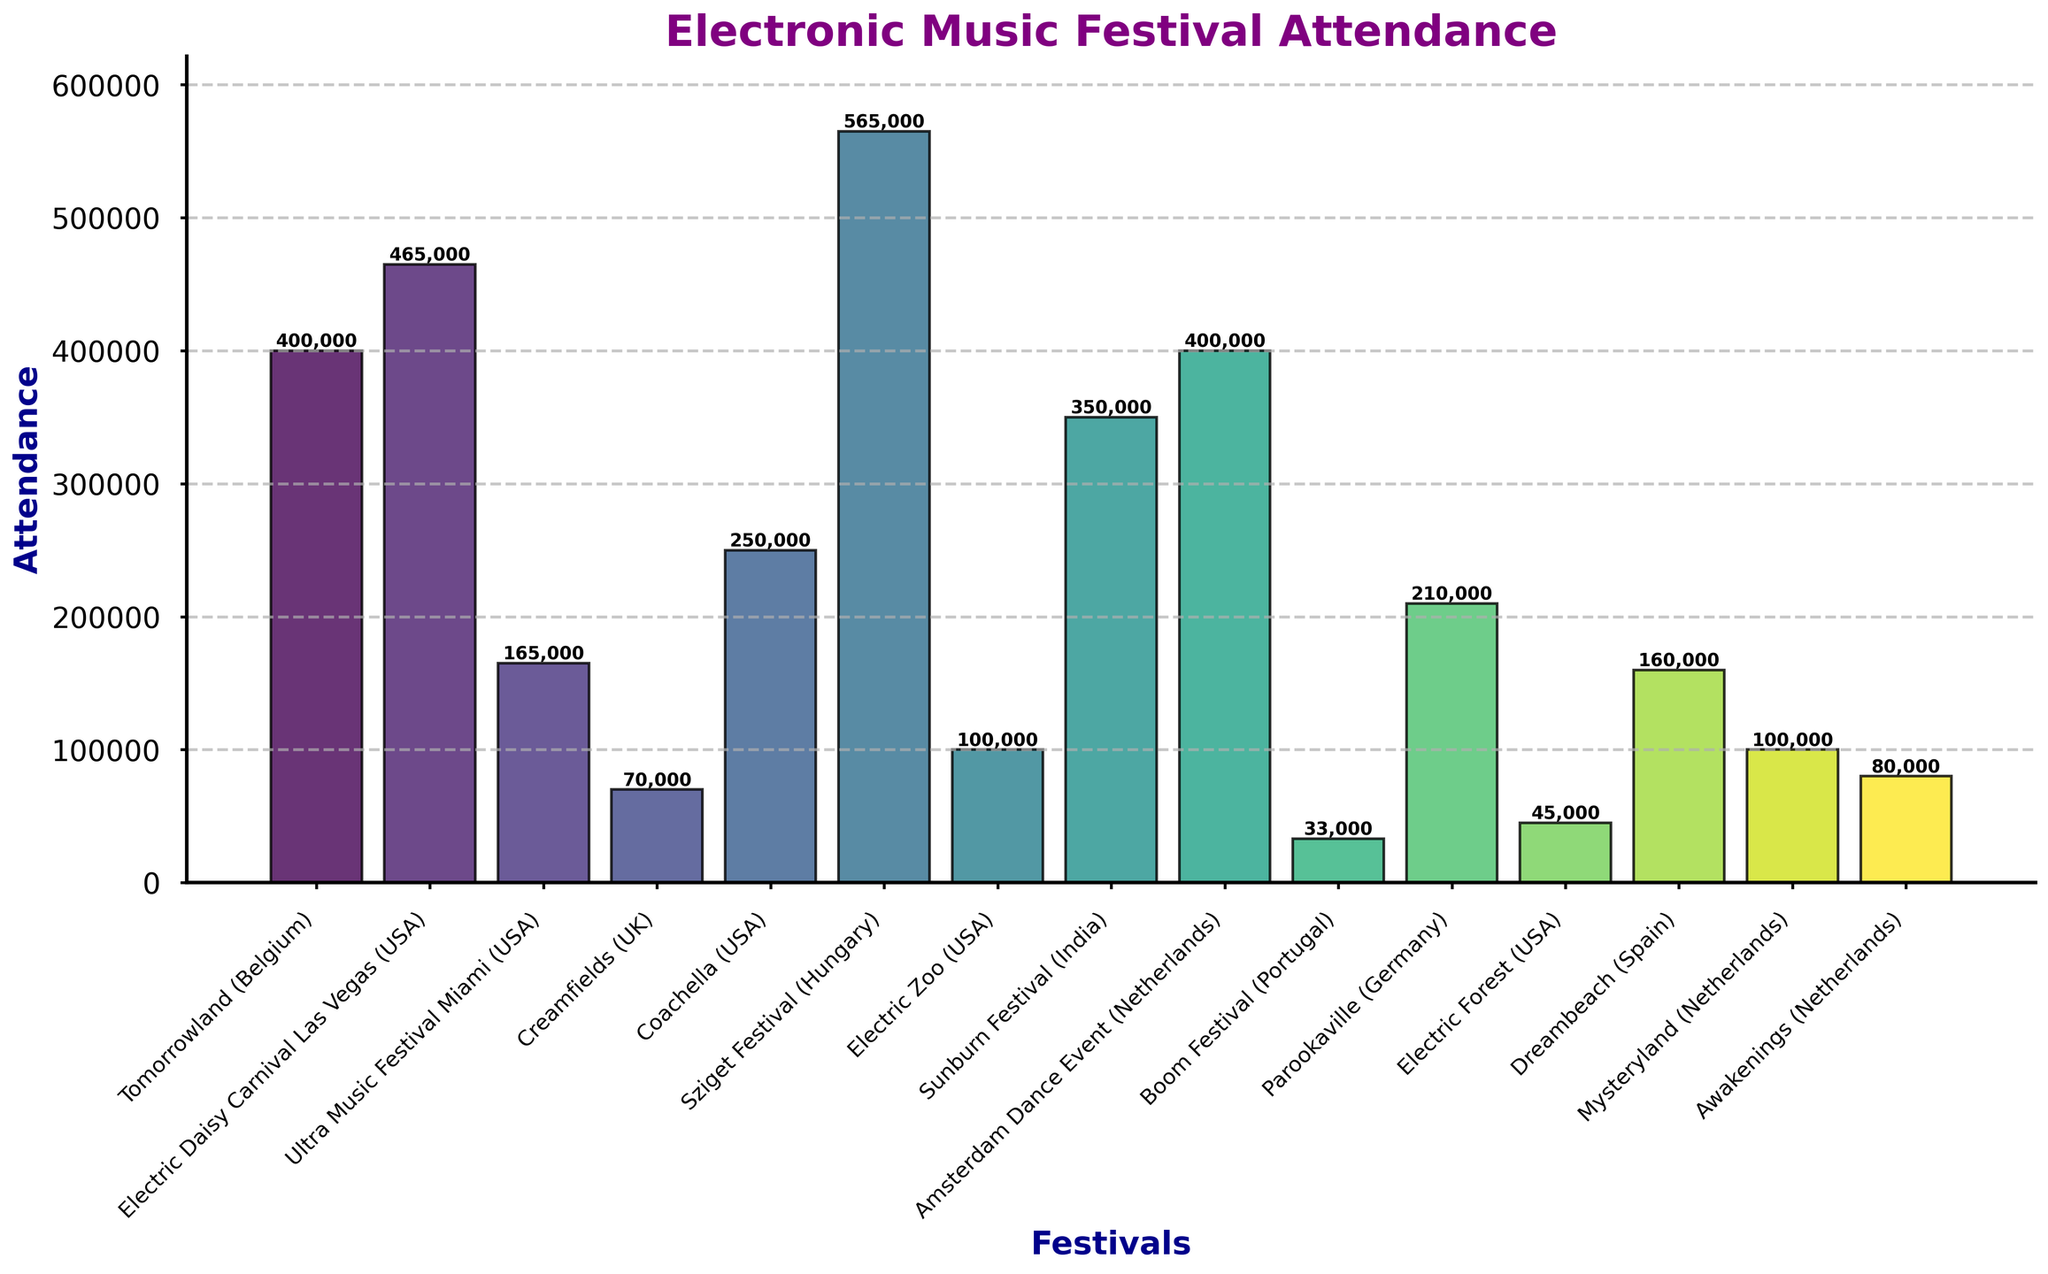Which festival has the highest attendance? The highest bar in the figure represents the festival with the highest attendance. By looking at the top of each bar, Sziget Festival in Hungary has the highest attendance of 565,000.
Answer: Sziget Festival (Hungary) Which festivals have equal attendance figures and what are they? By examining the height of the bars, Tomorrowland in Belgium and Amsterdam Dance Event in the Netherlands both have an attendance figure of 400,000.
Answer: Tomorrowland (Belgium) & Amsterdam Dance Event (Netherlands) What is the difference in attendance between Electric Daisy Carnival Las Vegas (USA) and Boom Festival (Portugal)? The height of the bar for Electric Daisy Carnival Las Vegas (USA) shows 465,000 and for Boom Festival (Portugal) it shows 33,000. Subtracting the attendance of Boom Festival from Electric Daisy Carnival Las Vegas gives 465,000 - 33,000 = 432,000.
Answer: 432,000 What is the total attendance of the festivals in the USA? Adding up the bars representing festivals in the USA which are Electric Daisy Carnival Las Vegas (465,000), Ultra Music Festival Miami (165,000), Coachella (250,000), Electric Zoo (100,000), and Electric Forest (45,000), the sum is 465,000 + 165,000 + 250,000 + 100,000 + 45,000 = 1,025,000.
Answer: 1,025,000 Which festival has the smallest attendance, and what is the difference in attendance between this festival and Sziget Festival (Hungary)? The shortest bar in the figure represents Boom Festival (Portugal) with an attendance of 33,000. Subtracting this from the highest attendance of 565,000 of Sziget Festival gives a difference of 565,000 - 33,000 = 532,000.
Answer: Boom Festival (Portugal), 532,000 What is the average attendance of all listed festivals? To find the average, sum all the attendance figures and divide by the number of festivals. The total sum is 400,000 + 465,000 + 165,000 + 70,000 + 250,000 + 565,000 + 100,000 + 350,000 + 400,000 + 33,000 + 210,000 + 45,000 + 160,000 + 100,000 + 80,000 = 3,393,000. There are 15 festivals, so the average is 3,393,000 / 15 = 226,200.
Answer: 226,200 Which festivals have an attendance greater than 300,000 but less than 500,000? By observing the height of the bars, the festivals that have attendance within this range are Tomorrowland (400,000), Electric Daisy Carnival Las Vegas (465,000), Sunburn Festival (350,000), and Amsterdam Dance Event (400,000).
Answer: Tomorrowland (Belgium), Electric Daisy Carnival Las Vegas (USA), Sunburn Festival (India), Amsterdam Dance Event (Netherlands) What is the median attendance figure for the festivals? To find the median, list all attendance figures in ascending order: 33,000, 45,000, 70,000, 80,000, 100,000, 100,000, 160,000, 165,000, 210,000, 250,000, 330,000, 350,000, 400,000, 400,000, 465,000, 565,000. The middle value (8th and 9th) are 165,000 and 210,000, so the median is (165,000 + 210,000) / 2 = 187,500.
Answer: 187,500 Which country has the highest cumulative attendance across its festivals? By summing the attendance figures for each country:
- USA: 465,000 (EDC) + 165,000 (Ultra) + 250,000 (Coachella) + 100,000 (Electric Zoo) + 45,000 (Electric Forest) = 1,025,000
- Netherlands: 400,000 (ADE) + 100,000 (Mysteryland) + 80,000 (Awakenings) = 580,000
- Other countries have fewer festivals/is less cumulative.
Thus, the USA has the highest cumulative attendance.
Answer: USA 